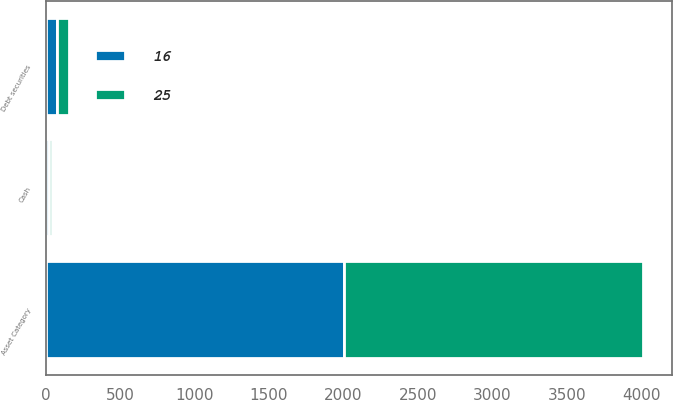<chart> <loc_0><loc_0><loc_500><loc_500><stacked_bar_chart><ecel><fcel>Asset Category<fcel>Debt securities<fcel>Cash<nl><fcel>16<fcel>2005<fcel>75<fcel>25<nl><fcel>25<fcel>2004<fcel>84<fcel>16<nl></chart> 